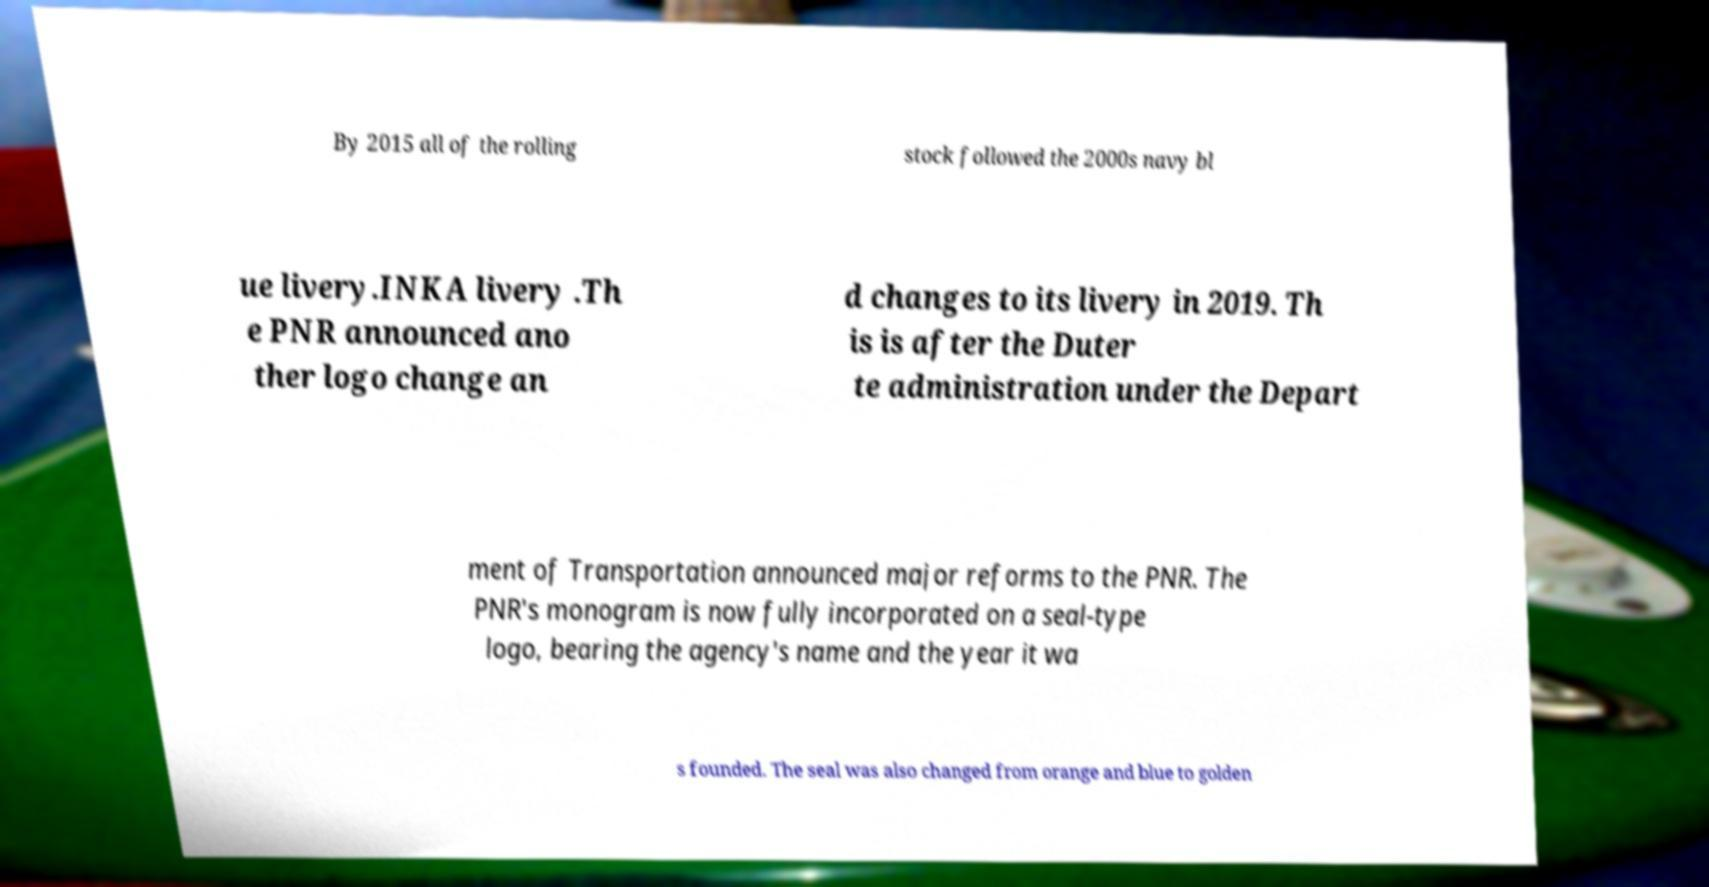What messages or text are displayed in this image? I need them in a readable, typed format. By 2015 all of the rolling stock followed the 2000s navy bl ue livery.INKA livery .Th e PNR announced ano ther logo change an d changes to its livery in 2019. Th is is after the Duter te administration under the Depart ment of Transportation announced major reforms to the PNR. The PNR's monogram is now fully incorporated on a seal-type logo, bearing the agency's name and the year it wa s founded. The seal was also changed from orange and blue to golden 